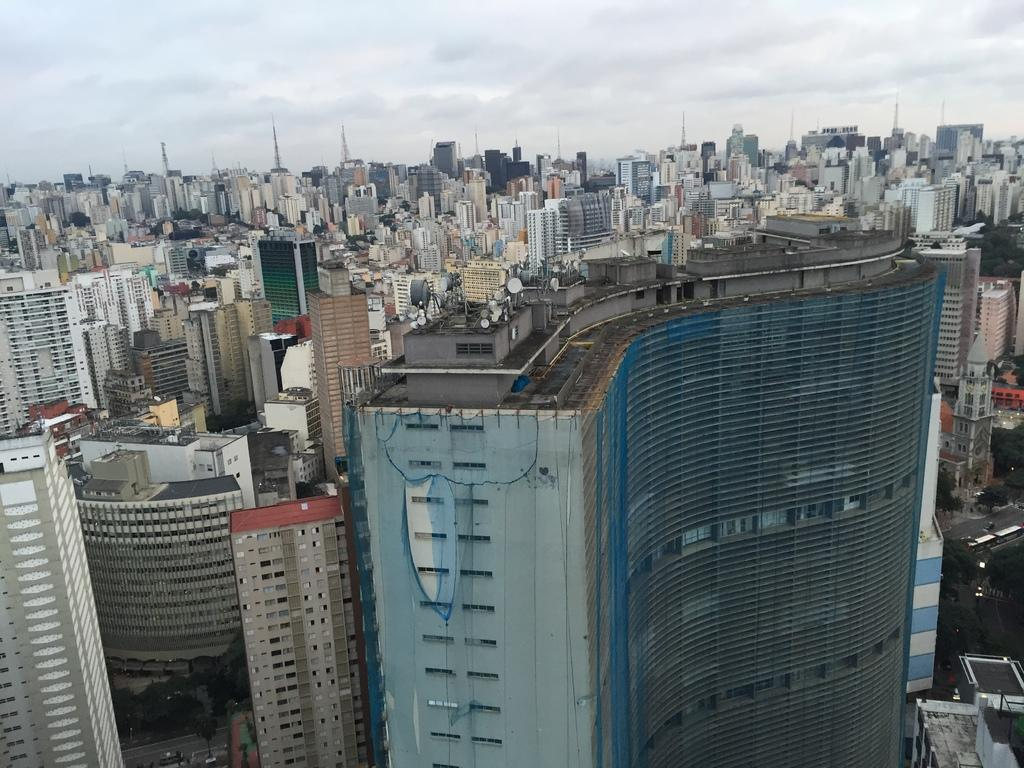What type of structures can be seen in the image? There is a group of buildings in the image. What specific features are present on some of the buildings? There are towers in the image. What type of vegetation is present in the image? There are trees in the image. What is attached to a wall in the image? There is a net on a wall in the image. How would you describe the sky in the image? The sky is visible in the image and appears cloudy. Where is the parcel being delivered in the image? There is no parcel present in the image. Can you see a plane flying in the sky in the image? There is no plane visible in the sky in the image. 